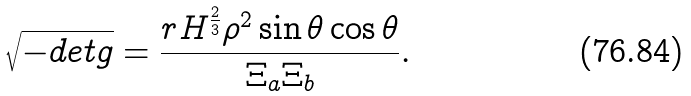<formula> <loc_0><loc_0><loc_500><loc_500>\sqrt { - d e t g } = \frac { r H ^ { \frac { 2 } { 3 } } \rho ^ { 2 } \sin \theta \cos \theta } { \Xi _ { a } \Xi _ { b } } .</formula> 